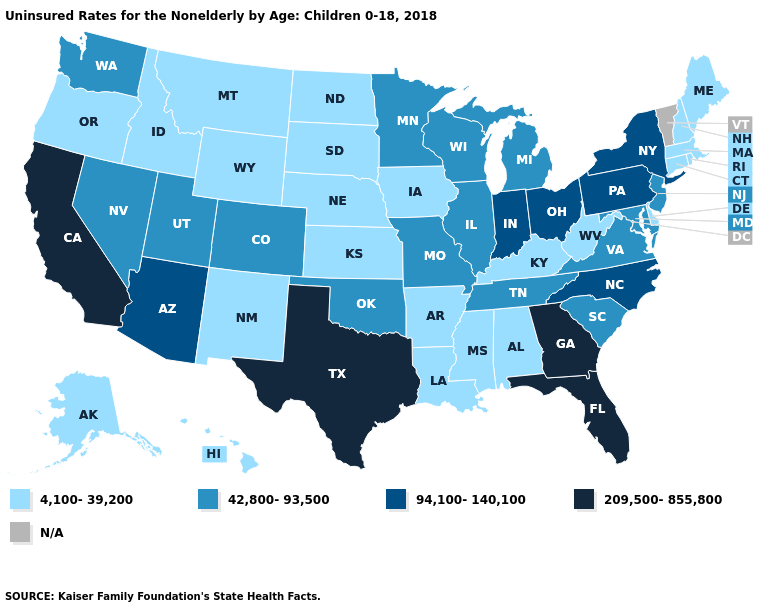Does the map have missing data?
Short answer required. Yes. Which states hav the highest value in the MidWest?
Answer briefly. Indiana, Ohio. Name the states that have a value in the range 94,100-140,100?
Quick response, please. Arizona, Indiana, New York, North Carolina, Ohio, Pennsylvania. What is the highest value in the USA?
Short answer required. 209,500-855,800. Does California have the highest value in the USA?
Concise answer only. Yes. Which states have the lowest value in the USA?
Quick response, please. Alabama, Alaska, Arkansas, Connecticut, Delaware, Hawaii, Idaho, Iowa, Kansas, Kentucky, Louisiana, Maine, Massachusetts, Mississippi, Montana, Nebraska, New Hampshire, New Mexico, North Dakota, Oregon, Rhode Island, South Dakota, West Virginia, Wyoming. What is the highest value in states that border West Virginia?
Write a very short answer. 94,100-140,100. Which states hav the highest value in the MidWest?
Be succinct. Indiana, Ohio. Which states have the lowest value in the USA?
Give a very brief answer. Alabama, Alaska, Arkansas, Connecticut, Delaware, Hawaii, Idaho, Iowa, Kansas, Kentucky, Louisiana, Maine, Massachusetts, Mississippi, Montana, Nebraska, New Hampshire, New Mexico, North Dakota, Oregon, Rhode Island, South Dakota, West Virginia, Wyoming. What is the lowest value in states that border Georgia?
Be succinct. 4,100-39,200. What is the value of North Dakota?
Quick response, please. 4,100-39,200. Which states hav the highest value in the MidWest?
Concise answer only. Indiana, Ohio. What is the value of Utah?
Quick response, please. 42,800-93,500. 